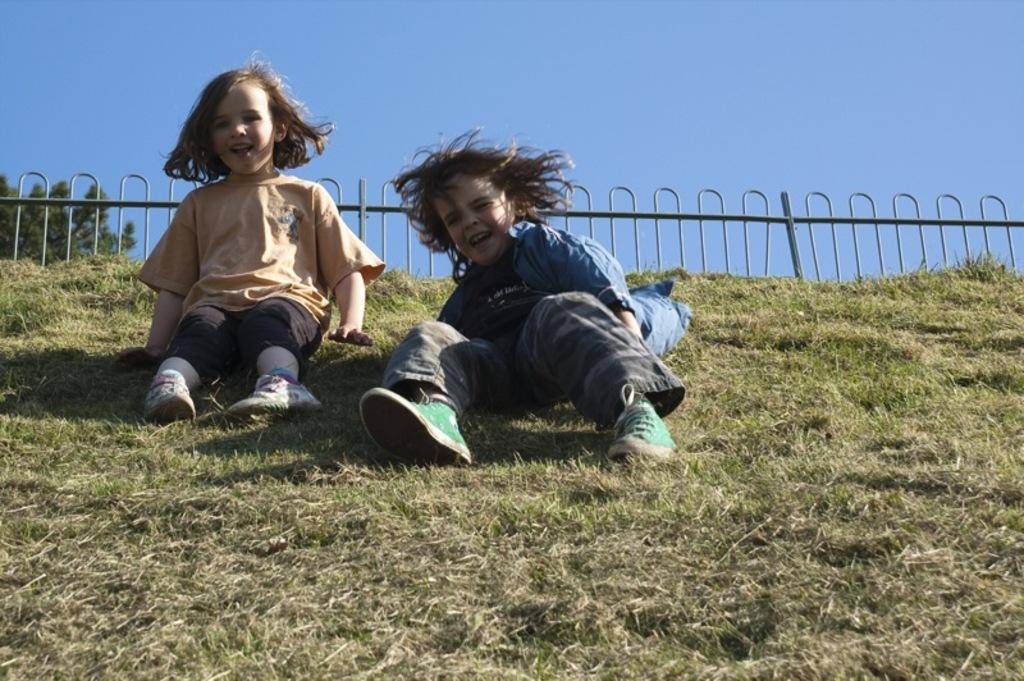What is the main subject in the foreground of the image? There are kids in the foreground of the image. What are the kids doing in the image? One kid is sitting on the grass, and another kid appears to be sliding on the grass. What can be seen in the background of the image? There is railing, a tree, and the sky visible in the background of the image. What is the name of the bee buzzing around the kids in the image? There is no bee present in the image, so it is not possible to determine its name. 